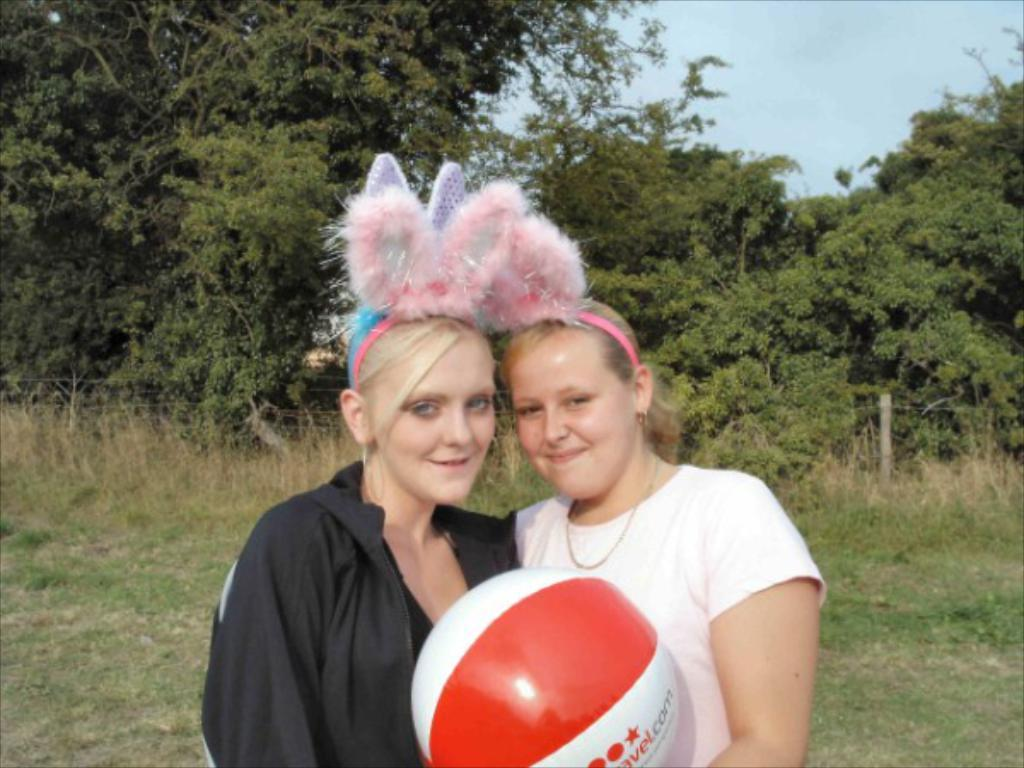How many people are in the picture? There are two girls in the picture. What are the girls holding in the picture? The girls are holding a ball. What are the girls wearing on their heads? The girls are wearing headbands. What can be seen in the background of the picture? There are trees and a blue sky in the background of the picture. What type of finger food is visible in the picture? There is no finger food present in the picture; it features two girls holding a ball and wearing headbands. Can you see any bun-shaped objects in the picture? There are no bun-shaped objects present in the picture. 